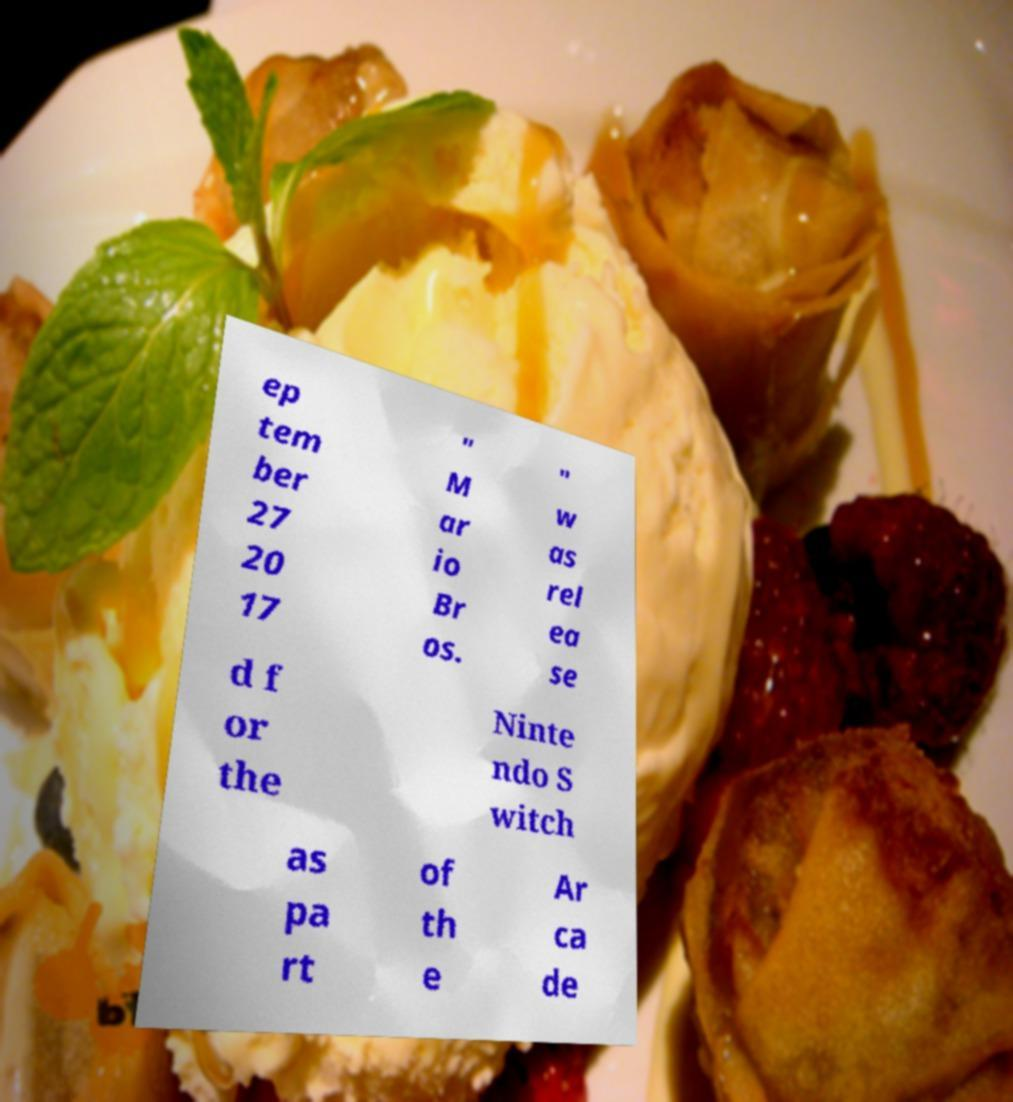Could you extract and type out the text from this image? ep tem ber 27 20 17 " M ar io Br os. " w as rel ea se d f or the Ninte ndo S witch as pa rt of th e Ar ca de 